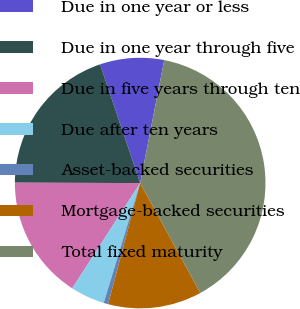<chart> <loc_0><loc_0><loc_500><loc_500><pie_chart><fcel>Due in one year or less<fcel>Due in one year through five<fcel>Due in five years through ten<fcel>Due after ten years<fcel>Asset-backed securities<fcel>Mortgage-backed securities<fcel>Total fixed maturity<nl><fcel>8.26%<fcel>19.77%<fcel>15.93%<fcel>4.42%<fcel>0.58%<fcel>12.09%<fcel>38.96%<nl></chart> 